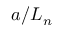Convert formula to latex. <formula><loc_0><loc_0><loc_500><loc_500>a / L _ { n }</formula> 